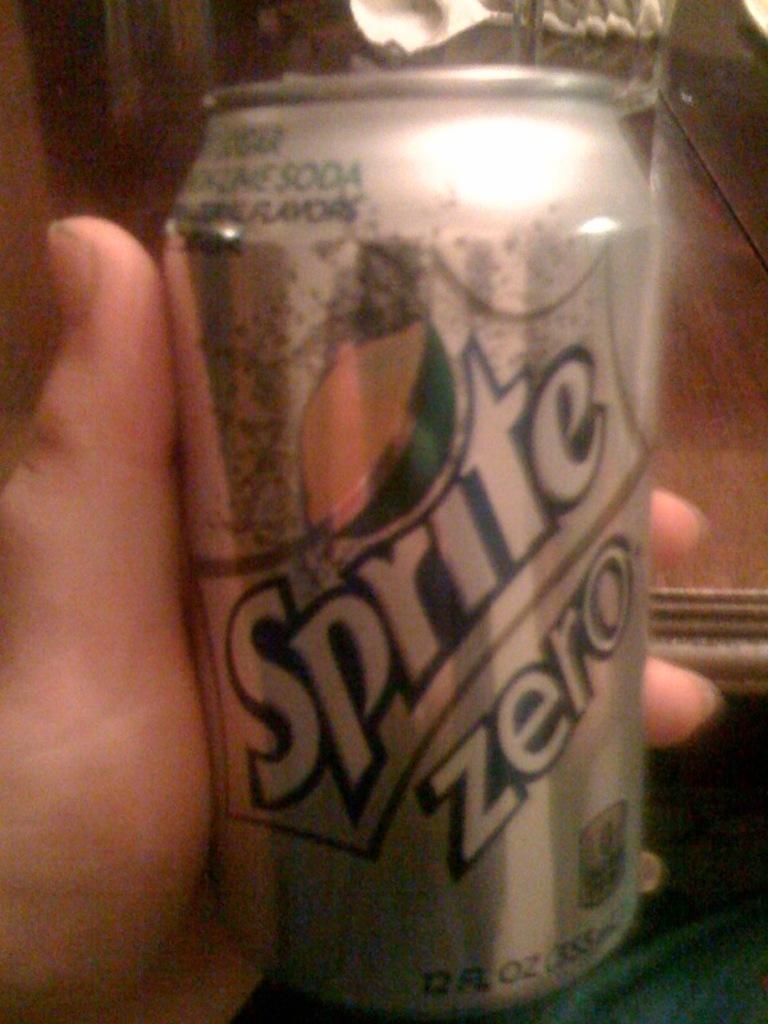How would you summarize this image in a sentence or two? In the image there is a person holding soft drink tin. 